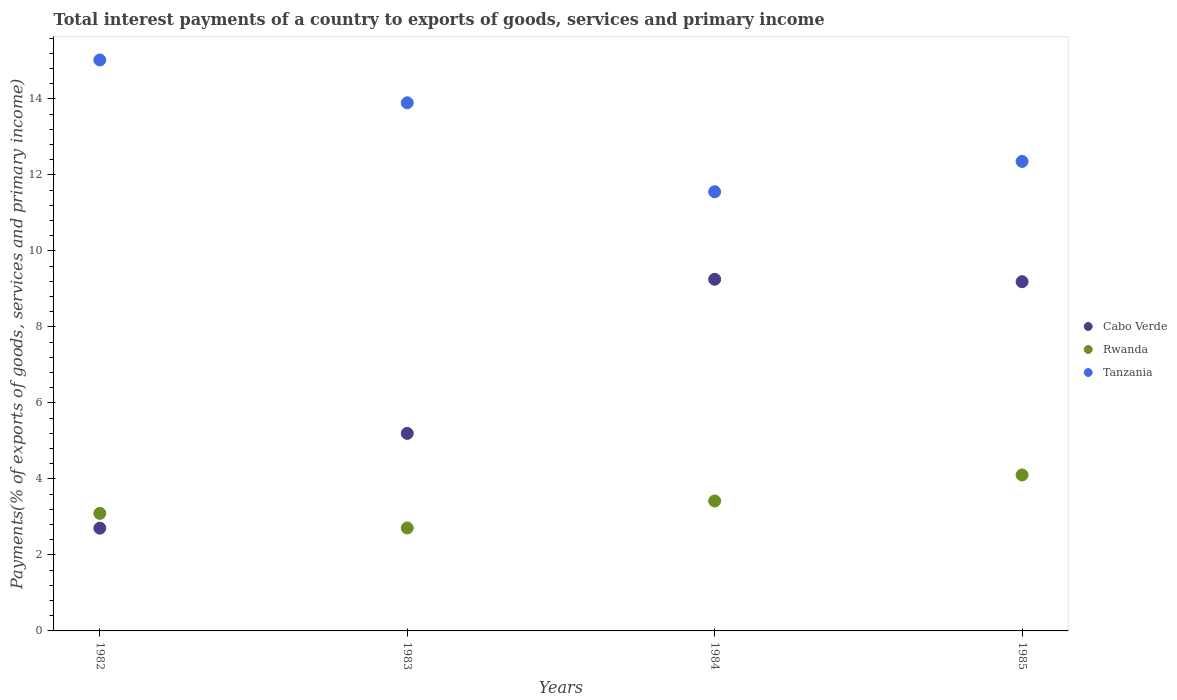How many different coloured dotlines are there?
Your answer should be very brief. 3. What is the total interest payments in Rwanda in 1983?
Make the answer very short. 2.71. Across all years, what is the maximum total interest payments in Tanzania?
Ensure brevity in your answer.  15.03. Across all years, what is the minimum total interest payments in Tanzania?
Provide a short and direct response. 11.56. In which year was the total interest payments in Rwanda maximum?
Keep it short and to the point. 1985. What is the total total interest payments in Rwanda in the graph?
Provide a short and direct response. 13.33. What is the difference between the total interest payments in Rwanda in 1984 and that in 1985?
Keep it short and to the point. -0.68. What is the difference between the total interest payments in Rwanda in 1985 and the total interest payments in Cabo Verde in 1983?
Your answer should be compact. -1.09. What is the average total interest payments in Cabo Verde per year?
Keep it short and to the point. 6.59. In the year 1985, what is the difference between the total interest payments in Rwanda and total interest payments in Cabo Verde?
Your answer should be very brief. -5.09. What is the ratio of the total interest payments in Tanzania in 1984 to that in 1985?
Make the answer very short. 0.94. Is the difference between the total interest payments in Rwanda in 1984 and 1985 greater than the difference between the total interest payments in Cabo Verde in 1984 and 1985?
Your response must be concise. No. What is the difference between the highest and the second highest total interest payments in Rwanda?
Your response must be concise. 0.68. What is the difference between the highest and the lowest total interest payments in Rwanda?
Make the answer very short. 1.4. In how many years, is the total interest payments in Cabo Verde greater than the average total interest payments in Cabo Verde taken over all years?
Keep it short and to the point. 2. Is the sum of the total interest payments in Tanzania in 1984 and 1985 greater than the maximum total interest payments in Rwanda across all years?
Your answer should be compact. Yes. Does the total interest payments in Tanzania monotonically increase over the years?
Your response must be concise. No. How many years are there in the graph?
Make the answer very short. 4. Does the graph contain any zero values?
Provide a short and direct response. No. Does the graph contain grids?
Your response must be concise. No. How are the legend labels stacked?
Provide a short and direct response. Vertical. What is the title of the graph?
Your response must be concise. Total interest payments of a country to exports of goods, services and primary income. Does "Chile" appear as one of the legend labels in the graph?
Provide a short and direct response. No. What is the label or title of the X-axis?
Provide a succinct answer. Years. What is the label or title of the Y-axis?
Your response must be concise. Payments(% of exports of goods, services and primary income). What is the Payments(% of exports of goods, services and primary income) of Cabo Verde in 1982?
Give a very brief answer. 2.7. What is the Payments(% of exports of goods, services and primary income) in Rwanda in 1982?
Your answer should be very brief. 3.09. What is the Payments(% of exports of goods, services and primary income) in Tanzania in 1982?
Ensure brevity in your answer.  15.03. What is the Payments(% of exports of goods, services and primary income) of Cabo Verde in 1983?
Ensure brevity in your answer.  5.2. What is the Payments(% of exports of goods, services and primary income) in Rwanda in 1983?
Provide a short and direct response. 2.71. What is the Payments(% of exports of goods, services and primary income) in Tanzania in 1983?
Give a very brief answer. 13.9. What is the Payments(% of exports of goods, services and primary income) of Cabo Verde in 1984?
Your answer should be very brief. 9.26. What is the Payments(% of exports of goods, services and primary income) in Rwanda in 1984?
Your answer should be compact. 3.42. What is the Payments(% of exports of goods, services and primary income) of Tanzania in 1984?
Keep it short and to the point. 11.56. What is the Payments(% of exports of goods, services and primary income) in Cabo Verde in 1985?
Make the answer very short. 9.19. What is the Payments(% of exports of goods, services and primary income) in Rwanda in 1985?
Your response must be concise. 4.11. What is the Payments(% of exports of goods, services and primary income) in Tanzania in 1985?
Provide a short and direct response. 12.36. Across all years, what is the maximum Payments(% of exports of goods, services and primary income) of Cabo Verde?
Give a very brief answer. 9.26. Across all years, what is the maximum Payments(% of exports of goods, services and primary income) of Rwanda?
Your answer should be compact. 4.11. Across all years, what is the maximum Payments(% of exports of goods, services and primary income) in Tanzania?
Provide a succinct answer. 15.03. Across all years, what is the minimum Payments(% of exports of goods, services and primary income) in Cabo Verde?
Ensure brevity in your answer.  2.7. Across all years, what is the minimum Payments(% of exports of goods, services and primary income) in Rwanda?
Offer a terse response. 2.71. Across all years, what is the minimum Payments(% of exports of goods, services and primary income) of Tanzania?
Give a very brief answer. 11.56. What is the total Payments(% of exports of goods, services and primary income) of Cabo Verde in the graph?
Your answer should be compact. 26.35. What is the total Payments(% of exports of goods, services and primary income) of Rwanda in the graph?
Your answer should be compact. 13.33. What is the total Payments(% of exports of goods, services and primary income) in Tanzania in the graph?
Keep it short and to the point. 52.84. What is the difference between the Payments(% of exports of goods, services and primary income) in Cabo Verde in 1982 and that in 1983?
Ensure brevity in your answer.  -2.49. What is the difference between the Payments(% of exports of goods, services and primary income) in Rwanda in 1982 and that in 1983?
Your response must be concise. 0.38. What is the difference between the Payments(% of exports of goods, services and primary income) in Tanzania in 1982 and that in 1983?
Offer a terse response. 1.13. What is the difference between the Payments(% of exports of goods, services and primary income) in Cabo Verde in 1982 and that in 1984?
Your answer should be very brief. -6.55. What is the difference between the Payments(% of exports of goods, services and primary income) of Rwanda in 1982 and that in 1984?
Make the answer very short. -0.33. What is the difference between the Payments(% of exports of goods, services and primary income) of Tanzania in 1982 and that in 1984?
Your response must be concise. 3.47. What is the difference between the Payments(% of exports of goods, services and primary income) in Cabo Verde in 1982 and that in 1985?
Give a very brief answer. -6.49. What is the difference between the Payments(% of exports of goods, services and primary income) in Rwanda in 1982 and that in 1985?
Offer a very short reply. -1.01. What is the difference between the Payments(% of exports of goods, services and primary income) in Tanzania in 1982 and that in 1985?
Give a very brief answer. 2.67. What is the difference between the Payments(% of exports of goods, services and primary income) in Cabo Verde in 1983 and that in 1984?
Provide a succinct answer. -4.06. What is the difference between the Payments(% of exports of goods, services and primary income) of Rwanda in 1983 and that in 1984?
Your answer should be compact. -0.71. What is the difference between the Payments(% of exports of goods, services and primary income) in Tanzania in 1983 and that in 1984?
Offer a terse response. 2.34. What is the difference between the Payments(% of exports of goods, services and primary income) in Cabo Verde in 1983 and that in 1985?
Provide a short and direct response. -3.99. What is the difference between the Payments(% of exports of goods, services and primary income) of Rwanda in 1983 and that in 1985?
Offer a terse response. -1.4. What is the difference between the Payments(% of exports of goods, services and primary income) in Tanzania in 1983 and that in 1985?
Keep it short and to the point. 1.54. What is the difference between the Payments(% of exports of goods, services and primary income) in Cabo Verde in 1984 and that in 1985?
Your answer should be very brief. 0.06. What is the difference between the Payments(% of exports of goods, services and primary income) in Rwanda in 1984 and that in 1985?
Give a very brief answer. -0.68. What is the difference between the Payments(% of exports of goods, services and primary income) of Tanzania in 1984 and that in 1985?
Give a very brief answer. -0.8. What is the difference between the Payments(% of exports of goods, services and primary income) in Cabo Verde in 1982 and the Payments(% of exports of goods, services and primary income) in Rwanda in 1983?
Give a very brief answer. -0. What is the difference between the Payments(% of exports of goods, services and primary income) of Cabo Verde in 1982 and the Payments(% of exports of goods, services and primary income) of Tanzania in 1983?
Offer a terse response. -11.2. What is the difference between the Payments(% of exports of goods, services and primary income) of Rwanda in 1982 and the Payments(% of exports of goods, services and primary income) of Tanzania in 1983?
Give a very brief answer. -10.81. What is the difference between the Payments(% of exports of goods, services and primary income) of Cabo Verde in 1982 and the Payments(% of exports of goods, services and primary income) of Rwanda in 1984?
Give a very brief answer. -0.72. What is the difference between the Payments(% of exports of goods, services and primary income) of Cabo Verde in 1982 and the Payments(% of exports of goods, services and primary income) of Tanzania in 1984?
Your answer should be compact. -8.85. What is the difference between the Payments(% of exports of goods, services and primary income) in Rwanda in 1982 and the Payments(% of exports of goods, services and primary income) in Tanzania in 1984?
Your answer should be very brief. -8.47. What is the difference between the Payments(% of exports of goods, services and primary income) in Cabo Verde in 1982 and the Payments(% of exports of goods, services and primary income) in Rwanda in 1985?
Your answer should be compact. -1.4. What is the difference between the Payments(% of exports of goods, services and primary income) in Cabo Verde in 1982 and the Payments(% of exports of goods, services and primary income) in Tanzania in 1985?
Offer a very short reply. -9.65. What is the difference between the Payments(% of exports of goods, services and primary income) in Rwanda in 1982 and the Payments(% of exports of goods, services and primary income) in Tanzania in 1985?
Your answer should be very brief. -9.26. What is the difference between the Payments(% of exports of goods, services and primary income) in Cabo Verde in 1983 and the Payments(% of exports of goods, services and primary income) in Rwanda in 1984?
Offer a terse response. 1.78. What is the difference between the Payments(% of exports of goods, services and primary income) of Cabo Verde in 1983 and the Payments(% of exports of goods, services and primary income) of Tanzania in 1984?
Provide a short and direct response. -6.36. What is the difference between the Payments(% of exports of goods, services and primary income) in Rwanda in 1983 and the Payments(% of exports of goods, services and primary income) in Tanzania in 1984?
Give a very brief answer. -8.85. What is the difference between the Payments(% of exports of goods, services and primary income) in Cabo Verde in 1983 and the Payments(% of exports of goods, services and primary income) in Rwanda in 1985?
Give a very brief answer. 1.09. What is the difference between the Payments(% of exports of goods, services and primary income) in Cabo Verde in 1983 and the Payments(% of exports of goods, services and primary income) in Tanzania in 1985?
Your response must be concise. -7.16. What is the difference between the Payments(% of exports of goods, services and primary income) in Rwanda in 1983 and the Payments(% of exports of goods, services and primary income) in Tanzania in 1985?
Keep it short and to the point. -9.65. What is the difference between the Payments(% of exports of goods, services and primary income) in Cabo Verde in 1984 and the Payments(% of exports of goods, services and primary income) in Rwanda in 1985?
Provide a succinct answer. 5.15. What is the difference between the Payments(% of exports of goods, services and primary income) of Cabo Verde in 1984 and the Payments(% of exports of goods, services and primary income) of Tanzania in 1985?
Provide a short and direct response. -3.1. What is the difference between the Payments(% of exports of goods, services and primary income) of Rwanda in 1984 and the Payments(% of exports of goods, services and primary income) of Tanzania in 1985?
Keep it short and to the point. -8.94. What is the average Payments(% of exports of goods, services and primary income) of Cabo Verde per year?
Provide a succinct answer. 6.59. What is the average Payments(% of exports of goods, services and primary income) in Rwanda per year?
Your response must be concise. 3.33. What is the average Payments(% of exports of goods, services and primary income) in Tanzania per year?
Make the answer very short. 13.21. In the year 1982, what is the difference between the Payments(% of exports of goods, services and primary income) of Cabo Verde and Payments(% of exports of goods, services and primary income) of Rwanda?
Offer a very short reply. -0.39. In the year 1982, what is the difference between the Payments(% of exports of goods, services and primary income) of Cabo Verde and Payments(% of exports of goods, services and primary income) of Tanzania?
Provide a short and direct response. -12.32. In the year 1982, what is the difference between the Payments(% of exports of goods, services and primary income) in Rwanda and Payments(% of exports of goods, services and primary income) in Tanzania?
Your response must be concise. -11.93. In the year 1983, what is the difference between the Payments(% of exports of goods, services and primary income) of Cabo Verde and Payments(% of exports of goods, services and primary income) of Rwanda?
Your answer should be very brief. 2.49. In the year 1983, what is the difference between the Payments(% of exports of goods, services and primary income) in Cabo Verde and Payments(% of exports of goods, services and primary income) in Tanzania?
Give a very brief answer. -8.7. In the year 1983, what is the difference between the Payments(% of exports of goods, services and primary income) of Rwanda and Payments(% of exports of goods, services and primary income) of Tanzania?
Your answer should be compact. -11.19. In the year 1984, what is the difference between the Payments(% of exports of goods, services and primary income) in Cabo Verde and Payments(% of exports of goods, services and primary income) in Rwanda?
Your answer should be compact. 5.83. In the year 1984, what is the difference between the Payments(% of exports of goods, services and primary income) of Cabo Verde and Payments(% of exports of goods, services and primary income) of Tanzania?
Offer a terse response. -2.3. In the year 1984, what is the difference between the Payments(% of exports of goods, services and primary income) in Rwanda and Payments(% of exports of goods, services and primary income) in Tanzania?
Your response must be concise. -8.14. In the year 1985, what is the difference between the Payments(% of exports of goods, services and primary income) of Cabo Verde and Payments(% of exports of goods, services and primary income) of Rwanda?
Provide a succinct answer. 5.09. In the year 1985, what is the difference between the Payments(% of exports of goods, services and primary income) in Cabo Verde and Payments(% of exports of goods, services and primary income) in Tanzania?
Make the answer very short. -3.17. In the year 1985, what is the difference between the Payments(% of exports of goods, services and primary income) in Rwanda and Payments(% of exports of goods, services and primary income) in Tanzania?
Your answer should be compact. -8.25. What is the ratio of the Payments(% of exports of goods, services and primary income) of Cabo Verde in 1982 to that in 1983?
Give a very brief answer. 0.52. What is the ratio of the Payments(% of exports of goods, services and primary income) in Rwanda in 1982 to that in 1983?
Give a very brief answer. 1.14. What is the ratio of the Payments(% of exports of goods, services and primary income) of Tanzania in 1982 to that in 1983?
Keep it short and to the point. 1.08. What is the ratio of the Payments(% of exports of goods, services and primary income) of Cabo Verde in 1982 to that in 1984?
Provide a succinct answer. 0.29. What is the ratio of the Payments(% of exports of goods, services and primary income) of Rwanda in 1982 to that in 1984?
Offer a very short reply. 0.9. What is the ratio of the Payments(% of exports of goods, services and primary income) in Cabo Verde in 1982 to that in 1985?
Keep it short and to the point. 0.29. What is the ratio of the Payments(% of exports of goods, services and primary income) in Rwanda in 1982 to that in 1985?
Offer a terse response. 0.75. What is the ratio of the Payments(% of exports of goods, services and primary income) of Tanzania in 1982 to that in 1985?
Ensure brevity in your answer.  1.22. What is the ratio of the Payments(% of exports of goods, services and primary income) in Cabo Verde in 1983 to that in 1984?
Make the answer very short. 0.56. What is the ratio of the Payments(% of exports of goods, services and primary income) in Rwanda in 1983 to that in 1984?
Provide a short and direct response. 0.79. What is the ratio of the Payments(% of exports of goods, services and primary income) of Tanzania in 1983 to that in 1984?
Your answer should be compact. 1.2. What is the ratio of the Payments(% of exports of goods, services and primary income) of Cabo Verde in 1983 to that in 1985?
Your answer should be compact. 0.57. What is the ratio of the Payments(% of exports of goods, services and primary income) in Rwanda in 1983 to that in 1985?
Offer a terse response. 0.66. What is the ratio of the Payments(% of exports of goods, services and primary income) in Tanzania in 1983 to that in 1985?
Provide a succinct answer. 1.12. What is the ratio of the Payments(% of exports of goods, services and primary income) in Rwanda in 1984 to that in 1985?
Offer a terse response. 0.83. What is the ratio of the Payments(% of exports of goods, services and primary income) in Tanzania in 1984 to that in 1985?
Provide a short and direct response. 0.94. What is the difference between the highest and the second highest Payments(% of exports of goods, services and primary income) of Cabo Verde?
Give a very brief answer. 0.06. What is the difference between the highest and the second highest Payments(% of exports of goods, services and primary income) of Rwanda?
Give a very brief answer. 0.68. What is the difference between the highest and the second highest Payments(% of exports of goods, services and primary income) in Tanzania?
Your answer should be compact. 1.13. What is the difference between the highest and the lowest Payments(% of exports of goods, services and primary income) in Cabo Verde?
Make the answer very short. 6.55. What is the difference between the highest and the lowest Payments(% of exports of goods, services and primary income) in Rwanda?
Your response must be concise. 1.4. What is the difference between the highest and the lowest Payments(% of exports of goods, services and primary income) in Tanzania?
Give a very brief answer. 3.47. 